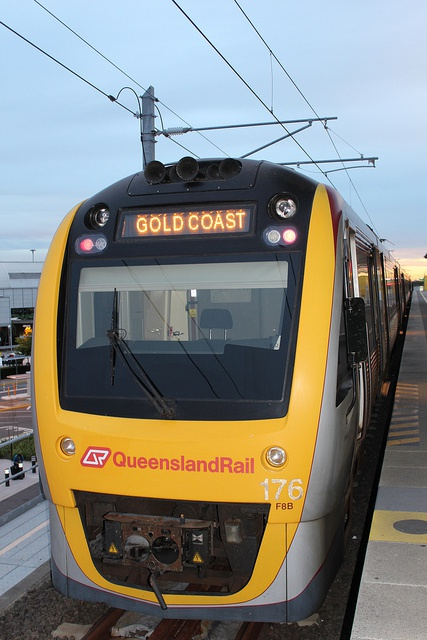Describe the objects in this image and their specific colors. I can see a train in lightblue, black, orange, gray, and darkgray tones in this image. 